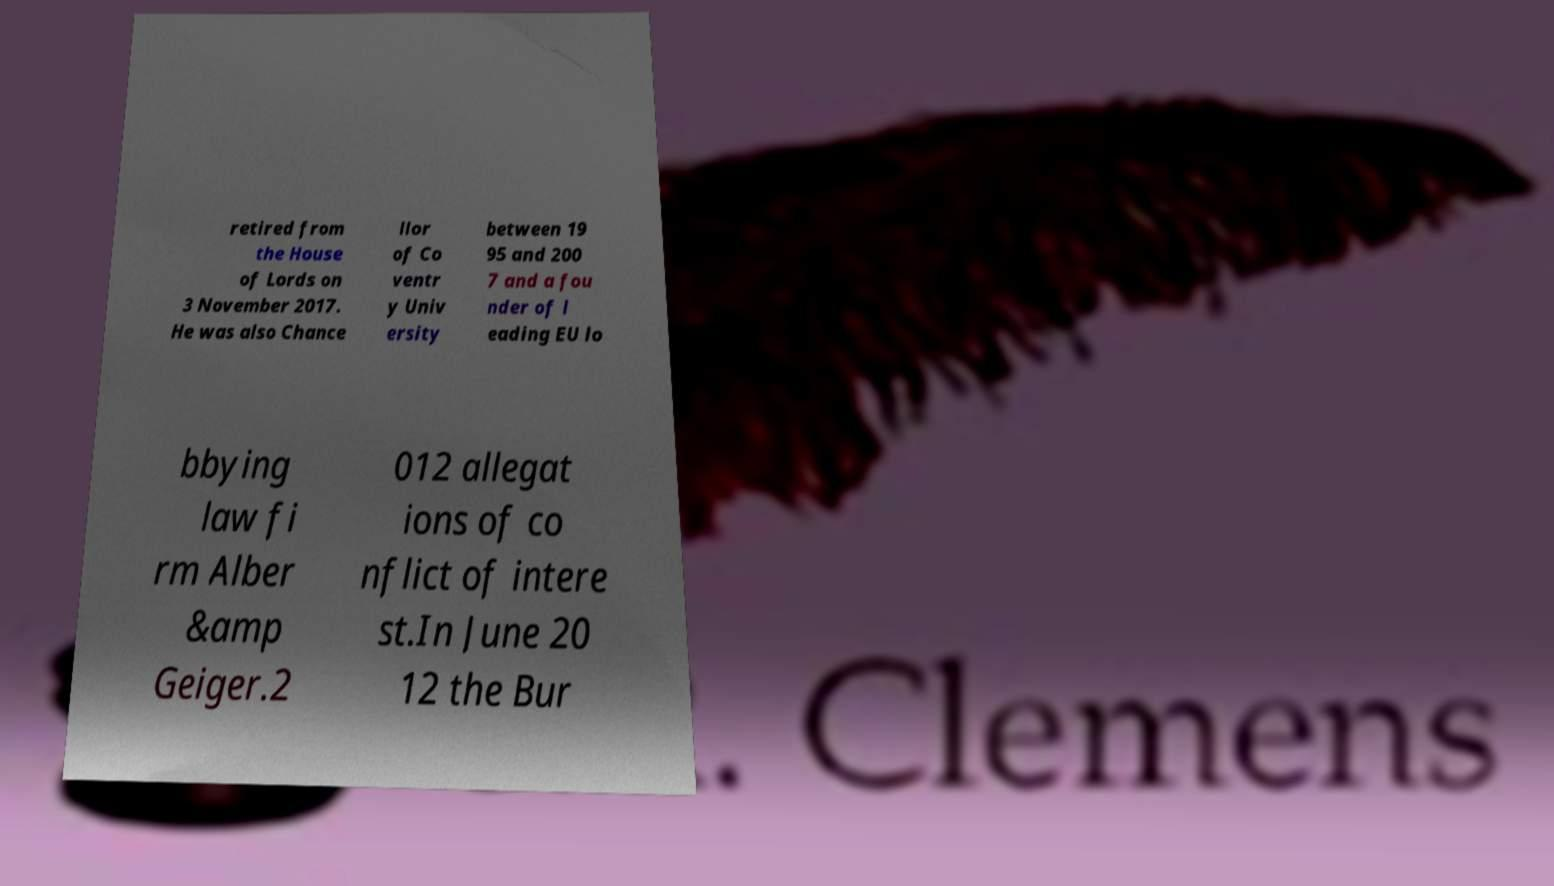Please read and relay the text visible in this image. What does it say? retired from the House of Lords on 3 November 2017. He was also Chance llor of Co ventr y Univ ersity between 19 95 and 200 7 and a fou nder of l eading EU lo bbying law fi rm Alber &amp Geiger.2 012 allegat ions of co nflict of intere st.In June 20 12 the Bur 